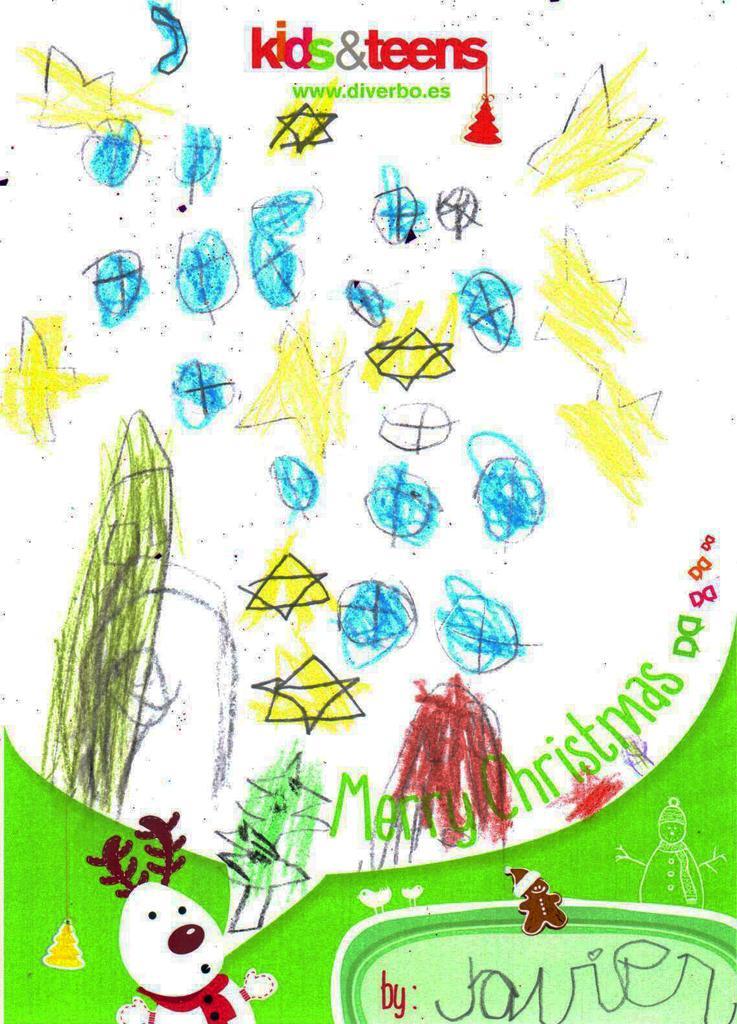Please provide a concise description of this image. In this image, we can see a painting and some text written on it. 